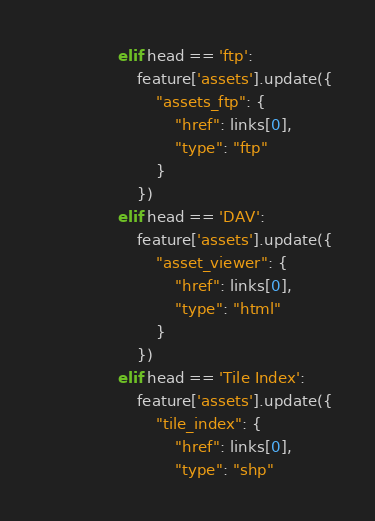Convert code to text. <code><loc_0><loc_0><loc_500><loc_500><_Python_>                elif head == 'ftp':
                    feature['assets'].update({
                        "assets_ftp": {
                            "href": links[0],
                            "type": "ftp"
                        }
                    })
                elif head == 'DAV':
                    feature['assets'].update({
                        "asset_viewer": {
                            "href": links[0],
                            "type": "html"
                        }
                    })
                elif head == 'Tile Index':
                    feature['assets'].update({
                        "tile_index": {
                            "href": links[0],
                            "type": "shp"</code> 